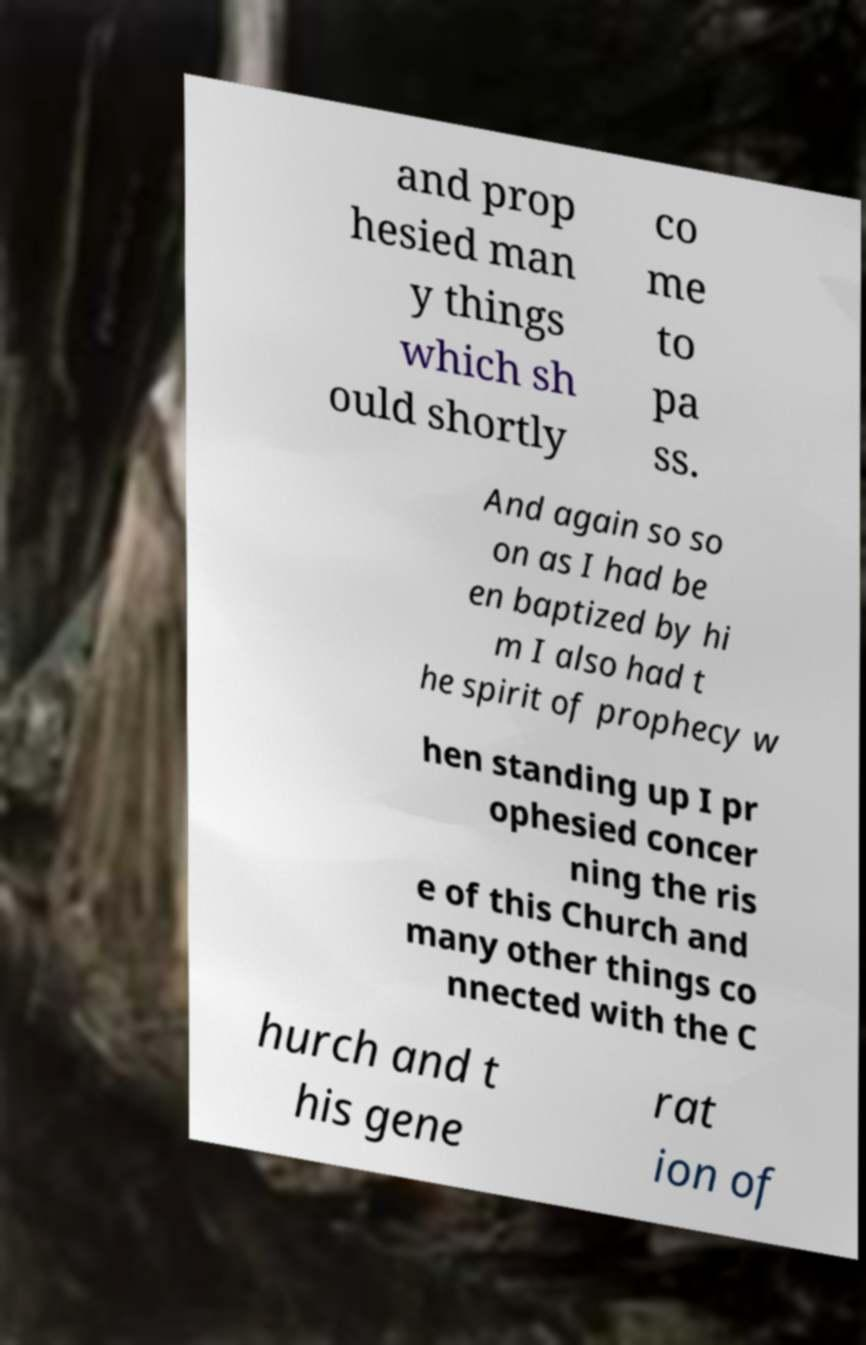Can you accurately transcribe the text from the provided image for me? and prop hesied man y things which sh ould shortly co me to pa ss. And again so so on as I had be en baptized by hi m I also had t he spirit of prophecy w hen standing up I pr ophesied concer ning the ris e of this Church and many other things co nnected with the C hurch and t his gene rat ion of 